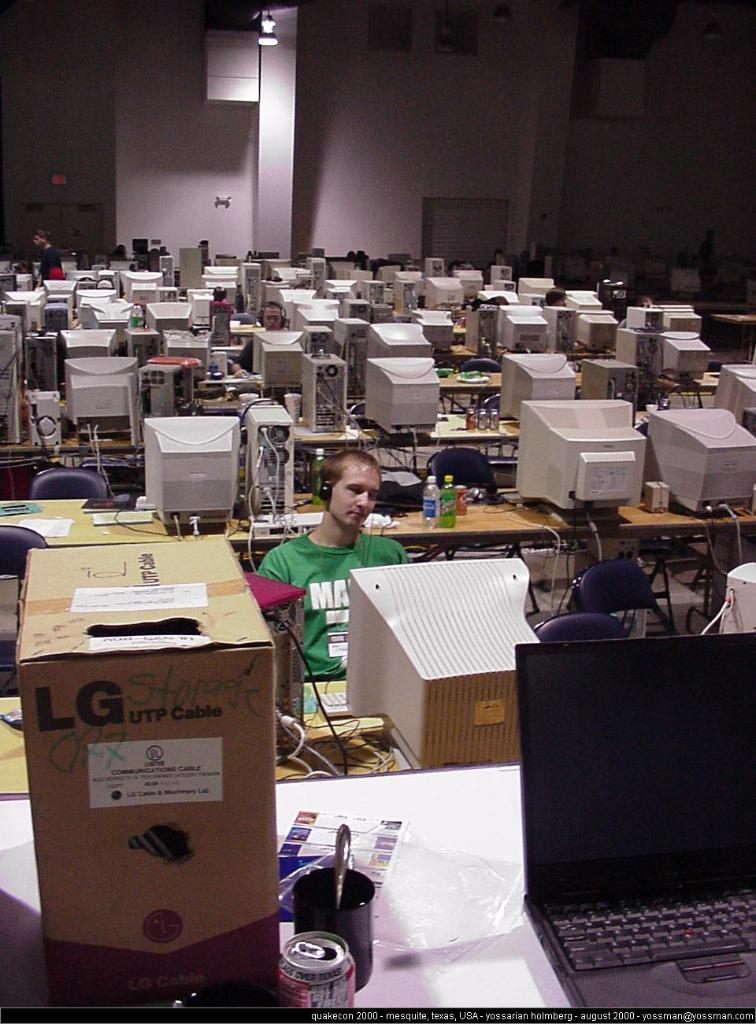<image>
Provide a brief description of the given image. A cardbox box that says LG UTP Cable sits at the forefront of a computer room.. 